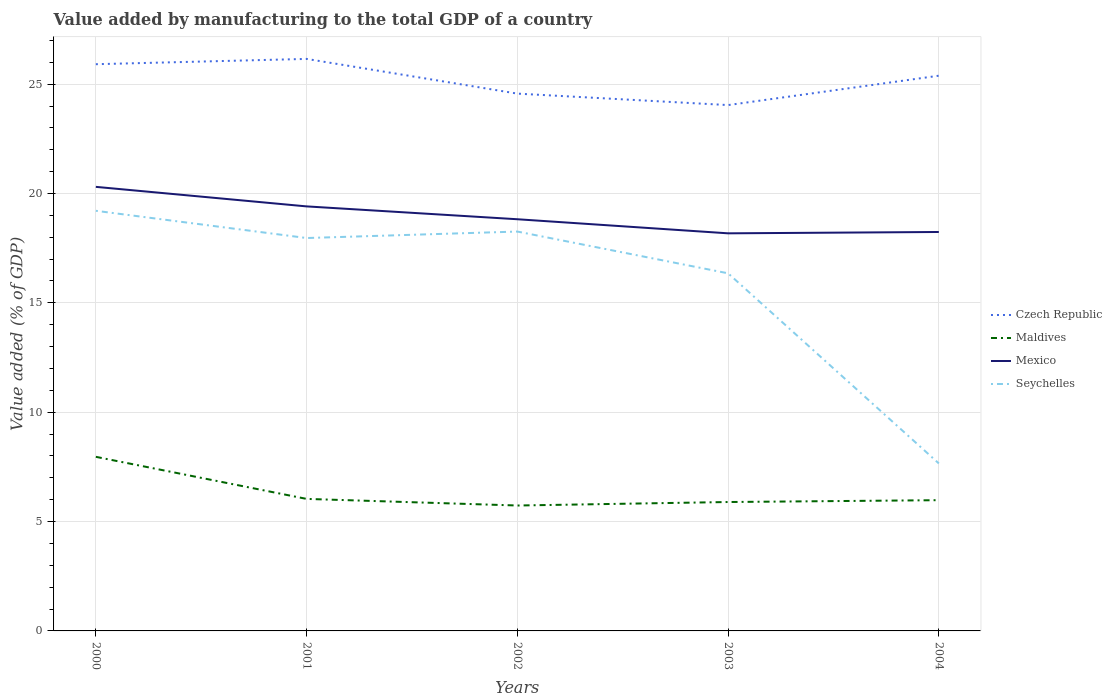How many different coloured lines are there?
Offer a very short reply. 4. Across all years, what is the maximum value added by manufacturing to the total GDP in Maldives?
Make the answer very short. 5.73. In which year was the value added by manufacturing to the total GDP in Maldives maximum?
Give a very brief answer. 2002. What is the total value added by manufacturing to the total GDP in Seychelles in the graph?
Give a very brief answer. 1.91. What is the difference between the highest and the second highest value added by manufacturing to the total GDP in Mexico?
Offer a very short reply. 2.13. What is the difference between the highest and the lowest value added by manufacturing to the total GDP in Czech Republic?
Ensure brevity in your answer.  3. Are the values on the major ticks of Y-axis written in scientific E-notation?
Ensure brevity in your answer.  No. Does the graph contain any zero values?
Make the answer very short. No. How many legend labels are there?
Make the answer very short. 4. How are the legend labels stacked?
Give a very brief answer. Vertical. What is the title of the graph?
Provide a short and direct response. Value added by manufacturing to the total GDP of a country. Does "Slovenia" appear as one of the legend labels in the graph?
Make the answer very short. No. What is the label or title of the X-axis?
Provide a short and direct response. Years. What is the label or title of the Y-axis?
Ensure brevity in your answer.  Value added (% of GDP). What is the Value added (% of GDP) of Czech Republic in 2000?
Provide a short and direct response. 25.91. What is the Value added (% of GDP) of Maldives in 2000?
Provide a short and direct response. 7.96. What is the Value added (% of GDP) of Mexico in 2000?
Provide a succinct answer. 20.3. What is the Value added (% of GDP) of Seychelles in 2000?
Your answer should be compact. 19.21. What is the Value added (% of GDP) in Czech Republic in 2001?
Give a very brief answer. 26.16. What is the Value added (% of GDP) of Maldives in 2001?
Offer a very short reply. 6.04. What is the Value added (% of GDP) in Mexico in 2001?
Your answer should be very brief. 19.41. What is the Value added (% of GDP) in Seychelles in 2001?
Keep it short and to the point. 17.96. What is the Value added (% of GDP) of Czech Republic in 2002?
Your answer should be compact. 24.57. What is the Value added (% of GDP) in Maldives in 2002?
Give a very brief answer. 5.73. What is the Value added (% of GDP) in Mexico in 2002?
Offer a very short reply. 18.82. What is the Value added (% of GDP) of Seychelles in 2002?
Your answer should be compact. 18.26. What is the Value added (% of GDP) of Czech Republic in 2003?
Keep it short and to the point. 24.04. What is the Value added (% of GDP) in Maldives in 2003?
Offer a very short reply. 5.89. What is the Value added (% of GDP) in Mexico in 2003?
Make the answer very short. 18.18. What is the Value added (% of GDP) of Seychelles in 2003?
Your answer should be very brief. 16.35. What is the Value added (% of GDP) in Czech Republic in 2004?
Offer a very short reply. 25.39. What is the Value added (% of GDP) of Maldives in 2004?
Your answer should be compact. 5.98. What is the Value added (% of GDP) of Mexico in 2004?
Your answer should be very brief. 18.24. What is the Value added (% of GDP) in Seychelles in 2004?
Provide a succinct answer. 7.66. Across all years, what is the maximum Value added (% of GDP) of Czech Republic?
Provide a succinct answer. 26.16. Across all years, what is the maximum Value added (% of GDP) of Maldives?
Offer a very short reply. 7.96. Across all years, what is the maximum Value added (% of GDP) of Mexico?
Your response must be concise. 20.3. Across all years, what is the maximum Value added (% of GDP) in Seychelles?
Offer a very short reply. 19.21. Across all years, what is the minimum Value added (% of GDP) in Czech Republic?
Provide a short and direct response. 24.04. Across all years, what is the minimum Value added (% of GDP) in Maldives?
Your answer should be very brief. 5.73. Across all years, what is the minimum Value added (% of GDP) of Mexico?
Provide a short and direct response. 18.18. Across all years, what is the minimum Value added (% of GDP) in Seychelles?
Your answer should be compact. 7.66. What is the total Value added (% of GDP) in Czech Republic in the graph?
Provide a succinct answer. 126.07. What is the total Value added (% of GDP) in Maldives in the graph?
Provide a succinct answer. 31.6. What is the total Value added (% of GDP) of Mexico in the graph?
Make the answer very short. 94.96. What is the total Value added (% of GDP) of Seychelles in the graph?
Ensure brevity in your answer.  79.44. What is the difference between the Value added (% of GDP) in Czech Republic in 2000 and that in 2001?
Offer a terse response. -0.24. What is the difference between the Value added (% of GDP) in Maldives in 2000 and that in 2001?
Offer a terse response. 1.92. What is the difference between the Value added (% of GDP) in Mexico in 2000 and that in 2001?
Give a very brief answer. 0.89. What is the difference between the Value added (% of GDP) in Seychelles in 2000 and that in 2001?
Provide a short and direct response. 1.25. What is the difference between the Value added (% of GDP) of Czech Republic in 2000 and that in 2002?
Offer a terse response. 1.34. What is the difference between the Value added (% of GDP) in Maldives in 2000 and that in 2002?
Provide a succinct answer. 2.23. What is the difference between the Value added (% of GDP) in Mexico in 2000 and that in 2002?
Provide a succinct answer. 1.48. What is the difference between the Value added (% of GDP) in Seychelles in 2000 and that in 2002?
Your answer should be very brief. 0.95. What is the difference between the Value added (% of GDP) in Czech Republic in 2000 and that in 2003?
Offer a terse response. 1.87. What is the difference between the Value added (% of GDP) in Maldives in 2000 and that in 2003?
Give a very brief answer. 2.07. What is the difference between the Value added (% of GDP) in Mexico in 2000 and that in 2003?
Keep it short and to the point. 2.13. What is the difference between the Value added (% of GDP) of Seychelles in 2000 and that in 2003?
Provide a short and direct response. 2.86. What is the difference between the Value added (% of GDP) of Czech Republic in 2000 and that in 2004?
Ensure brevity in your answer.  0.53. What is the difference between the Value added (% of GDP) in Maldives in 2000 and that in 2004?
Your answer should be very brief. 1.98. What is the difference between the Value added (% of GDP) of Mexico in 2000 and that in 2004?
Offer a very short reply. 2.06. What is the difference between the Value added (% of GDP) of Seychelles in 2000 and that in 2004?
Give a very brief answer. 11.55. What is the difference between the Value added (% of GDP) of Czech Republic in 2001 and that in 2002?
Keep it short and to the point. 1.59. What is the difference between the Value added (% of GDP) in Maldives in 2001 and that in 2002?
Keep it short and to the point. 0.3. What is the difference between the Value added (% of GDP) in Mexico in 2001 and that in 2002?
Offer a very short reply. 0.59. What is the difference between the Value added (% of GDP) of Seychelles in 2001 and that in 2002?
Keep it short and to the point. -0.3. What is the difference between the Value added (% of GDP) of Czech Republic in 2001 and that in 2003?
Provide a short and direct response. 2.11. What is the difference between the Value added (% of GDP) of Maldives in 2001 and that in 2003?
Keep it short and to the point. 0.14. What is the difference between the Value added (% of GDP) in Mexico in 2001 and that in 2003?
Offer a very short reply. 1.23. What is the difference between the Value added (% of GDP) in Seychelles in 2001 and that in 2003?
Give a very brief answer. 1.61. What is the difference between the Value added (% of GDP) of Czech Republic in 2001 and that in 2004?
Your answer should be compact. 0.77. What is the difference between the Value added (% of GDP) of Maldives in 2001 and that in 2004?
Provide a short and direct response. 0.06. What is the difference between the Value added (% of GDP) in Mexico in 2001 and that in 2004?
Your answer should be compact. 1.17. What is the difference between the Value added (% of GDP) of Seychelles in 2001 and that in 2004?
Give a very brief answer. 10.31. What is the difference between the Value added (% of GDP) of Czech Republic in 2002 and that in 2003?
Provide a short and direct response. 0.52. What is the difference between the Value added (% of GDP) of Maldives in 2002 and that in 2003?
Give a very brief answer. -0.16. What is the difference between the Value added (% of GDP) of Mexico in 2002 and that in 2003?
Ensure brevity in your answer.  0.64. What is the difference between the Value added (% of GDP) of Seychelles in 2002 and that in 2003?
Your answer should be very brief. 1.91. What is the difference between the Value added (% of GDP) of Czech Republic in 2002 and that in 2004?
Offer a terse response. -0.82. What is the difference between the Value added (% of GDP) in Maldives in 2002 and that in 2004?
Provide a succinct answer. -0.24. What is the difference between the Value added (% of GDP) in Mexico in 2002 and that in 2004?
Keep it short and to the point. 0.58. What is the difference between the Value added (% of GDP) of Seychelles in 2002 and that in 2004?
Give a very brief answer. 10.6. What is the difference between the Value added (% of GDP) of Czech Republic in 2003 and that in 2004?
Ensure brevity in your answer.  -1.34. What is the difference between the Value added (% of GDP) of Maldives in 2003 and that in 2004?
Make the answer very short. -0.08. What is the difference between the Value added (% of GDP) in Mexico in 2003 and that in 2004?
Provide a short and direct response. -0.06. What is the difference between the Value added (% of GDP) in Seychelles in 2003 and that in 2004?
Keep it short and to the point. 8.69. What is the difference between the Value added (% of GDP) in Czech Republic in 2000 and the Value added (% of GDP) in Maldives in 2001?
Your response must be concise. 19.88. What is the difference between the Value added (% of GDP) of Czech Republic in 2000 and the Value added (% of GDP) of Mexico in 2001?
Give a very brief answer. 6.5. What is the difference between the Value added (% of GDP) of Czech Republic in 2000 and the Value added (% of GDP) of Seychelles in 2001?
Provide a succinct answer. 7.95. What is the difference between the Value added (% of GDP) in Maldives in 2000 and the Value added (% of GDP) in Mexico in 2001?
Provide a succinct answer. -11.45. What is the difference between the Value added (% of GDP) in Maldives in 2000 and the Value added (% of GDP) in Seychelles in 2001?
Your answer should be very brief. -10. What is the difference between the Value added (% of GDP) of Mexico in 2000 and the Value added (% of GDP) of Seychelles in 2001?
Your answer should be very brief. 2.34. What is the difference between the Value added (% of GDP) of Czech Republic in 2000 and the Value added (% of GDP) of Maldives in 2002?
Your answer should be compact. 20.18. What is the difference between the Value added (% of GDP) of Czech Republic in 2000 and the Value added (% of GDP) of Mexico in 2002?
Offer a very short reply. 7.09. What is the difference between the Value added (% of GDP) of Czech Republic in 2000 and the Value added (% of GDP) of Seychelles in 2002?
Offer a very short reply. 7.65. What is the difference between the Value added (% of GDP) of Maldives in 2000 and the Value added (% of GDP) of Mexico in 2002?
Offer a terse response. -10.86. What is the difference between the Value added (% of GDP) of Maldives in 2000 and the Value added (% of GDP) of Seychelles in 2002?
Give a very brief answer. -10.3. What is the difference between the Value added (% of GDP) in Mexico in 2000 and the Value added (% of GDP) in Seychelles in 2002?
Offer a terse response. 2.04. What is the difference between the Value added (% of GDP) in Czech Republic in 2000 and the Value added (% of GDP) in Maldives in 2003?
Your answer should be compact. 20.02. What is the difference between the Value added (% of GDP) in Czech Republic in 2000 and the Value added (% of GDP) in Mexico in 2003?
Your answer should be very brief. 7.73. What is the difference between the Value added (% of GDP) in Czech Republic in 2000 and the Value added (% of GDP) in Seychelles in 2003?
Ensure brevity in your answer.  9.56. What is the difference between the Value added (% of GDP) in Maldives in 2000 and the Value added (% of GDP) in Mexico in 2003?
Give a very brief answer. -10.22. What is the difference between the Value added (% of GDP) in Maldives in 2000 and the Value added (% of GDP) in Seychelles in 2003?
Your answer should be compact. -8.39. What is the difference between the Value added (% of GDP) of Mexico in 2000 and the Value added (% of GDP) of Seychelles in 2003?
Make the answer very short. 3.95. What is the difference between the Value added (% of GDP) of Czech Republic in 2000 and the Value added (% of GDP) of Maldives in 2004?
Make the answer very short. 19.93. What is the difference between the Value added (% of GDP) in Czech Republic in 2000 and the Value added (% of GDP) in Mexico in 2004?
Keep it short and to the point. 7.67. What is the difference between the Value added (% of GDP) of Czech Republic in 2000 and the Value added (% of GDP) of Seychelles in 2004?
Ensure brevity in your answer.  18.26. What is the difference between the Value added (% of GDP) in Maldives in 2000 and the Value added (% of GDP) in Mexico in 2004?
Provide a short and direct response. -10.28. What is the difference between the Value added (% of GDP) in Maldives in 2000 and the Value added (% of GDP) in Seychelles in 2004?
Provide a succinct answer. 0.3. What is the difference between the Value added (% of GDP) of Mexico in 2000 and the Value added (% of GDP) of Seychelles in 2004?
Your answer should be compact. 12.65. What is the difference between the Value added (% of GDP) of Czech Republic in 2001 and the Value added (% of GDP) of Maldives in 2002?
Your answer should be compact. 20.42. What is the difference between the Value added (% of GDP) of Czech Republic in 2001 and the Value added (% of GDP) of Mexico in 2002?
Provide a short and direct response. 7.33. What is the difference between the Value added (% of GDP) of Czech Republic in 2001 and the Value added (% of GDP) of Seychelles in 2002?
Offer a terse response. 7.89. What is the difference between the Value added (% of GDP) of Maldives in 2001 and the Value added (% of GDP) of Mexico in 2002?
Provide a short and direct response. -12.79. What is the difference between the Value added (% of GDP) in Maldives in 2001 and the Value added (% of GDP) in Seychelles in 2002?
Make the answer very short. -12.22. What is the difference between the Value added (% of GDP) in Mexico in 2001 and the Value added (% of GDP) in Seychelles in 2002?
Ensure brevity in your answer.  1.15. What is the difference between the Value added (% of GDP) in Czech Republic in 2001 and the Value added (% of GDP) in Maldives in 2003?
Your answer should be compact. 20.26. What is the difference between the Value added (% of GDP) of Czech Republic in 2001 and the Value added (% of GDP) of Mexico in 2003?
Provide a succinct answer. 7.98. What is the difference between the Value added (% of GDP) in Czech Republic in 2001 and the Value added (% of GDP) in Seychelles in 2003?
Provide a succinct answer. 9.8. What is the difference between the Value added (% of GDP) of Maldives in 2001 and the Value added (% of GDP) of Mexico in 2003?
Provide a short and direct response. -12.14. What is the difference between the Value added (% of GDP) of Maldives in 2001 and the Value added (% of GDP) of Seychelles in 2003?
Ensure brevity in your answer.  -10.31. What is the difference between the Value added (% of GDP) in Mexico in 2001 and the Value added (% of GDP) in Seychelles in 2003?
Your response must be concise. 3.06. What is the difference between the Value added (% of GDP) in Czech Republic in 2001 and the Value added (% of GDP) in Maldives in 2004?
Offer a terse response. 20.18. What is the difference between the Value added (% of GDP) in Czech Republic in 2001 and the Value added (% of GDP) in Mexico in 2004?
Your response must be concise. 7.91. What is the difference between the Value added (% of GDP) of Czech Republic in 2001 and the Value added (% of GDP) of Seychelles in 2004?
Provide a short and direct response. 18.5. What is the difference between the Value added (% of GDP) in Maldives in 2001 and the Value added (% of GDP) in Mexico in 2004?
Ensure brevity in your answer.  -12.2. What is the difference between the Value added (% of GDP) of Maldives in 2001 and the Value added (% of GDP) of Seychelles in 2004?
Your response must be concise. -1.62. What is the difference between the Value added (% of GDP) of Mexico in 2001 and the Value added (% of GDP) of Seychelles in 2004?
Provide a succinct answer. 11.75. What is the difference between the Value added (% of GDP) of Czech Republic in 2002 and the Value added (% of GDP) of Maldives in 2003?
Ensure brevity in your answer.  18.67. What is the difference between the Value added (% of GDP) of Czech Republic in 2002 and the Value added (% of GDP) of Mexico in 2003?
Offer a very short reply. 6.39. What is the difference between the Value added (% of GDP) of Czech Republic in 2002 and the Value added (% of GDP) of Seychelles in 2003?
Offer a terse response. 8.22. What is the difference between the Value added (% of GDP) of Maldives in 2002 and the Value added (% of GDP) of Mexico in 2003?
Your answer should be compact. -12.45. What is the difference between the Value added (% of GDP) of Maldives in 2002 and the Value added (% of GDP) of Seychelles in 2003?
Make the answer very short. -10.62. What is the difference between the Value added (% of GDP) in Mexico in 2002 and the Value added (% of GDP) in Seychelles in 2003?
Ensure brevity in your answer.  2.47. What is the difference between the Value added (% of GDP) in Czech Republic in 2002 and the Value added (% of GDP) in Maldives in 2004?
Provide a succinct answer. 18.59. What is the difference between the Value added (% of GDP) of Czech Republic in 2002 and the Value added (% of GDP) of Mexico in 2004?
Your answer should be compact. 6.33. What is the difference between the Value added (% of GDP) of Czech Republic in 2002 and the Value added (% of GDP) of Seychelles in 2004?
Your answer should be very brief. 16.91. What is the difference between the Value added (% of GDP) in Maldives in 2002 and the Value added (% of GDP) in Mexico in 2004?
Provide a succinct answer. -12.51. What is the difference between the Value added (% of GDP) of Maldives in 2002 and the Value added (% of GDP) of Seychelles in 2004?
Keep it short and to the point. -1.92. What is the difference between the Value added (% of GDP) in Mexico in 2002 and the Value added (% of GDP) in Seychelles in 2004?
Ensure brevity in your answer.  11.17. What is the difference between the Value added (% of GDP) of Czech Republic in 2003 and the Value added (% of GDP) of Maldives in 2004?
Your answer should be very brief. 18.07. What is the difference between the Value added (% of GDP) of Czech Republic in 2003 and the Value added (% of GDP) of Mexico in 2004?
Give a very brief answer. 5.8. What is the difference between the Value added (% of GDP) in Czech Republic in 2003 and the Value added (% of GDP) in Seychelles in 2004?
Offer a terse response. 16.39. What is the difference between the Value added (% of GDP) in Maldives in 2003 and the Value added (% of GDP) in Mexico in 2004?
Make the answer very short. -12.35. What is the difference between the Value added (% of GDP) of Maldives in 2003 and the Value added (% of GDP) of Seychelles in 2004?
Make the answer very short. -1.76. What is the difference between the Value added (% of GDP) in Mexico in 2003 and the Value added (% of GDP) in Seychelles in 2004?
Ensure brevity in your answer.  10.52. What is the average Value added (% of GDP) of Czech Republic per year?
Give a very brief answer. 25.21. What is the average Value added (% of GDP) of Maldives per year?
Your answer should be compact. 6.32. What is the average Value added (% of GDP) of Mexico per year?
Offer a very short reply. 18.99. What is the average Value added (% of GDP) of Seychelles per year?
Your answer should be compact. 15.89. In the year 2000, what is the difference between the Value added (% of GDP) of Czech Republic and Value added (% of GDP) of Maldives?
Give a very brief answer. 17.95. In the year 2000, what is the difference between the Value added (% of GDP) in Czech Republic and Value added (% of GDP) in Mexico?
Make the answer very short. 5.61. In the year 2000, what is the difference between the Value added (% of GDP) in Czech Republic and Value added (% of GDP) in Seychelles?
Ensure brevity in your answer.  6.7. In the year 2000, what is the difference between the Value added (% of GDP) of Maldives and Value added (% of GDP) of Mexico?
Your answer should be compact. -12.34. In the year 2000, what is the difference between the Value added (% of GDP) of Maldives and Value added (% of GDP) of Seychelles?
Your answer should be very brief. -11.25. In the year 2000, what is the difference between the Value added (% of GDP) in Mexico and Value added (% of GDP) in Seychelles?
Make the answer very short. 1.09. In the year 2001, what is the difference between the Value added (% of GDP) in Czech Republic and Value added (% of GDP) in Maldives?
Your response must be concise. 20.12. In the year 2001, what is the difference between the Value added (% of GDP) in Czech Republic and Value added (% of GDP) in Mexico?
Give a very brief answer. 6.74. In the year 2001, what is the difference between the Value added (% of GDP) of Czech Republic and Value added (% of GDP) of Seychelles?
Offer a very short reply. 8.19. In the year 2001, what is the difference between the Value added (% of GDP) of Maldives and Value added (% of GDP) of Mexico?
Keep it short and to the point. -13.37. In the year 2001, what is the difference between the Value added (% of GDP) in Maldives and Value added (% of GDP) in Seychelles?
Your response must be concise. -11.93. In the year 2001, what is the difference between the Value added (% of GDP) in Mexico and Value added (% of GDP) in Seychelles?
Offer a terse response. 1.45. In the year 2002, what is the difference between the Value added (% of GDP) in Czech Republic and Value added (% of GDP) in Maldives?
Make the answer very short. 18.83. In the year 2002, what is the difference between the Value added (% of GDP) in Czech Republic and Value added (% of GDP) in Mexico?
Make the answer very short. 5.74. In the year 2002, what is the difference between the Value added (% of GDP) of Czech Republic and Value added (% of GDP) of Seychelles?
Your answer should be very brief. 6.31. In the year 2002, what is the difference between the Value added (% of GDP) in Maldives and Value added (% of GDP) in Mexico?
Ensure brevity in your answer.  -13.09. In the year 2002, what is the difference between the Value added (% of GDP) in Maldives and Value added (% of GDP) in Seychelles?
Make the answer very short. -12.53. In the year 2002, what is the difference between the Value added (% of GDP) in Mexico and Value added (% of GDP) in Seychelles?
Provide a succinct answer. 0.56. In the year 2003, what is the difference between the Value added (% of GDP) in Czech Republic and Value added (% of GDP) in Maldives?
Offer a terse response. 18.15. In the year 2003, what is the difference between the Value added (% of GDP) in Czech Republic and Value added (% of GDP) in Mexico?
Provide a short and direct response. 5.86. In the year 2003, what is the difference between the Value added (% of GDP) of Czech Republic and Value added (% of GDP) of Seychelles?
Give a very brief answer. 7.69. In the year 2003, what is the difference between the Value added (% of GDP) of Maldives and Value added (% of GDP) of Mexico?
Provide a short and direct response. -12.29. In the year 2003, what is the difference between the Value added (% of GDP) of Maldives and Value added (% of GDP) of Seychelles?
Ensure brevity in your answer.  -10.46. In the year 2003, what is the difference between the Value added (% of GDP) in Mexico and Value added (% of GDP) in Seychelles?
Keep it short and to the point. 1.83. In the year 2004, what is the difference between the Value added (% of GDP) of Czech Republic and Value added (% of GDP) of Maldives?
Your response must be concise. 19.41. In the year 2004, what is the difference between the Value added (% of GDP) of Czech Republic and Value added (% of GDP) of Mexico?
Ensure brevity in your answer.  7.15. In the year 2004, what is the difference between the Value added (% of GDP) in Czech Republic and Value added (% of GDP) in Seychelles?
Give a very brief answer. 17.73. In the year 2004, what is the difference between the Value added (% of GDP) of Maldives and Value added (% of GDP) of Mexico?
Your answer should be very brief. -12.26. In the year 2004, what is the difference between the Value added (% of GDP) in Maldives and Value added (% of GDP) in Seychelles?
Your response must be concise. -1.68. In the year 2004, what is the difference between the Value added (% of GDP) of Mexico and Value added (% of GDP) of Seychelles?
Give a very brief answer. 10.58. What is the ratio of the Value added (% of GDP) in Czech Republic in 2000 to that in 2001?
Your response must be concise. 0.99. What is the ratio of the Value added (% of GDP) in Maldives in 2000 to that in 2001?
Provide a succinct answer. 1.32. What is the ratio of the Value added (% of GDP) of Mexico in 2000 to that in 2001?
Ensure brevity in your answer.  1.05. What is the ratio of the Value added (% of GDP) of Seychelles in 2000 to that in 2001?
Your answer should be very brief. 1.07. What is the ratio of the Value added (% of GDP) in Czech Republic in 2000 to that in 2002?
Your answer should be compact. 1.05. What is the ratio of the Value added (% of GDP) in Maldives in 2000 to that in 2002?
Offer a very short reply. 1.39. What is the ratio of the Value added (% of GDP) in Mexico in 2000 to that in 2002?
Provide a succinct answer. 1.08. What is the ratio of the Value added (% of GDP) of Seychelles in 2000 to that in 2002?
Ensure brevity in your answer.  1.05. What is the ratio of the Value added (% of GDP) of Czech Republic in 2000 to that in 2003?
Ensure brevity in your answer.  1.08. What is the ratio of the Value added (% of GDP) of Maldives in 2000 to that in 2003?
Your response must be concise. 1.35. What is the ratio of the Value added (% of GDP) in Mexico in 2000 to that in 2003?
Provide a short and direct response. 1.12. What is the ratio of the Value added (% of GDP) of Seychelles in 2000 to that in 2003?
Ensure brevity in your answer.  1.17. What is the ratio of the Value added (% of GDP) of Czech Republic in 2000 to that in 2004?
Your answer should be very brief. 1.02. What is the ratio of the Value added (% of GDP) in Maldives in 2000 to that in 2004?
Offer a very short reply. 1.33. What is the ratio of the Value added (% of GDP) in Mexico in 2000 to that in 2004?
Provide a short and direct response. 1.11. What is the ratio of the Value added (% of GDP) of Seychelles in 2000 to that in 2004?
Offer a very short reply. 2.51. What is the ratio of the Value added (% of GDP) of Czech Republic in 2001 to that in 2002?
Your answer should be compact. 1.06. What is the ratio of the Value added (% of GDP) of Maldives in 2001 to that in 2002?
Offer a terse response. 1.05. What is the ratio of the Value added (% of GDP) of Mexico in 2001 to that in 2002?
Provide a succinct answer. 1.03. What is the ratio of the Value added (% of GDP) in Seychelles in 2001 to that in 2002?
Offer a very short reply. 0.98. What is the ratio of the Value added (% of GDP) of Czech Republic in 2001 to that in 2003?
Ensure brevity in your answer.  1.09. What is the ratio of the Value added (% of GDP) in Maldives in 2001 to that in 2003?
Ensure brevity in your answer.  1.02. What is the ratio of the Value added (% of GDP) in Mexico in 2001 to that in 2003?
Ensure brevity in your answer.  1.07. What is the ratio of the Value added (% of GDP) in Seychelles in 2001 to that in 2003?
Your answer should be compact. 1.1. What is the ratio of the Value added (% of GDP) of Czech Republic in 2001 to that in 2004?
Provide a short and direct response. 1.03. What is the ratio of the Value added (% of GDP) of Maldives in 2001 to that in 2004?
Your response must be concise. 1.01. What is the ratio of the Value added (% of GDP) of Mexico in 2001 to that in 2004?
Your response must be concise. 1.06. What is the ratio of the Value added (% of GDP) of Seychelles in 2001 to that in 2004?
Provide a short and direct response. 2.35. What is the ratio of the Value added (% of GDP) in Czech Republic in 2002 to that in 2003?
Provide a succinct answer. 1.02. What is the ratio of the Value added (% of GDP) of Maldives in 2002 to that in 2003?
Keep it short and to the point. 0.97. What is the ratio of the Value added (% of GDP) in Mexico in 2002 to that in 2003?
Keep it short and to the point. 1.04. What is the ratio of the Value added (% of GDP) in Seychelles in 2002 to that in 2003?
Your answer should be very brief. 1.12. What is the ratio of the Value added (% of GDP) of Czech Republic in 2002 to that in 2004?
Give a very brief answer. 0.97. What is the ratio of the Value added (% of GDP) in Maldives in 2002 to that in 2004?
Your answer should be very brief. 0.96. What is the ratio of the Value added (% of GDP) of Mexico in 2002 to that in 2004?
Offer a terse response. 1.03. What is the ratio of the Value added (% of GDP) in Seychelles in 2002 to that in 2004?
Give a very brief answer. 2.38. What is the ratio of the Value added (% of GDP) of Czech Republic in 2003 to that in 2004?
Your response must be concise. 0.95. What is the ratio of the Value added (% of GDP) in Mexico in 2003 to that in 2004?
Your answer should be compact. 1. What is the ratio of the Value added (% of GDP) in Seychelles in 2003 to that in 2004?
Offer a terse response. 2.14. What is the difference between the highest and the second highest Value added (% of GDP) in Czech Republic?
Your response must be concise. 0.24. What is the difference between the highest and the second highest Value added (% of GDP) of Maldives?
Offer a very short reply. 1.92. What is the difference between the highest and the second highest Value added (% of GDP) in Mexico?
Give a very brief answer. 0.89. What is the difference between the highest and the second highest Value added (% of GDP) in Seychelles?
Provide a succinct answer. 0.95. What is the difference between the highest and the lowest Value added (% of GDP) of Czech Republic?
Offer a very short reply. 2.11. What is the difference between the highest and the lowest Value added (% of GDP) of Maldives?
Provide a short and direct response. 2.23. What is the difference between the highest and the lowest Value added (% of GDP) in Mexico?
Provide a short and direct response. 2.13. What is the difference between the highest and the lowest Value added (% of GDP) in Seychelles?
Make the answer very short. 11.55. 